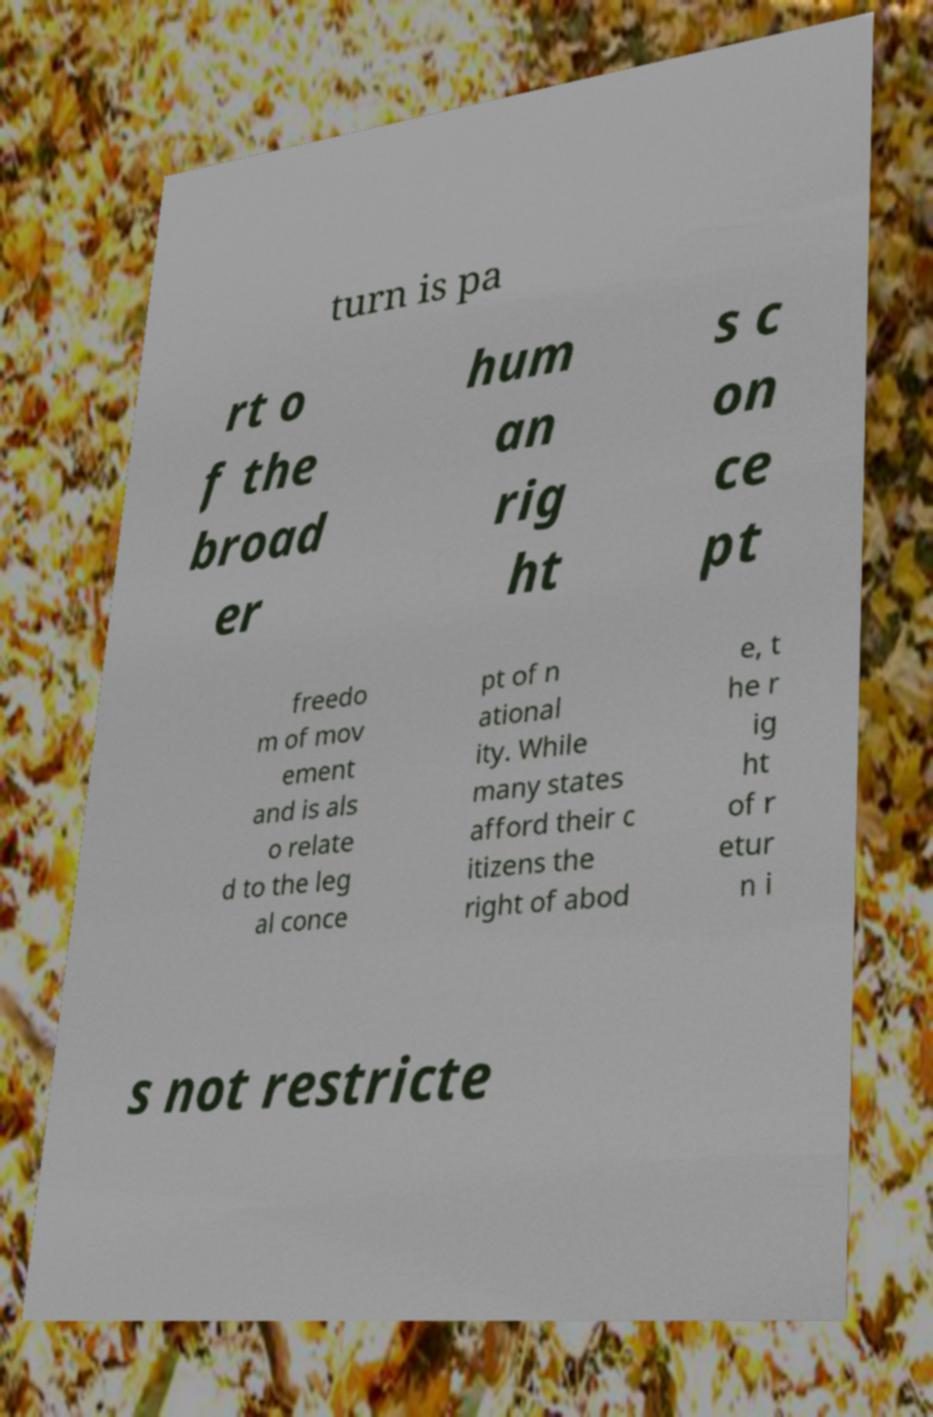For documentation purposes, I need the text within this image transcribed. Could you provide that? turn is pa rt o f the broad er hum an rig ht s c on ce pt freedo m of mov ement and is als o relate d to the leg al conce pt of n ational ity. While many states afford their c itizens the right of abod e, t he r ig ht of r etur n i s not restricte 